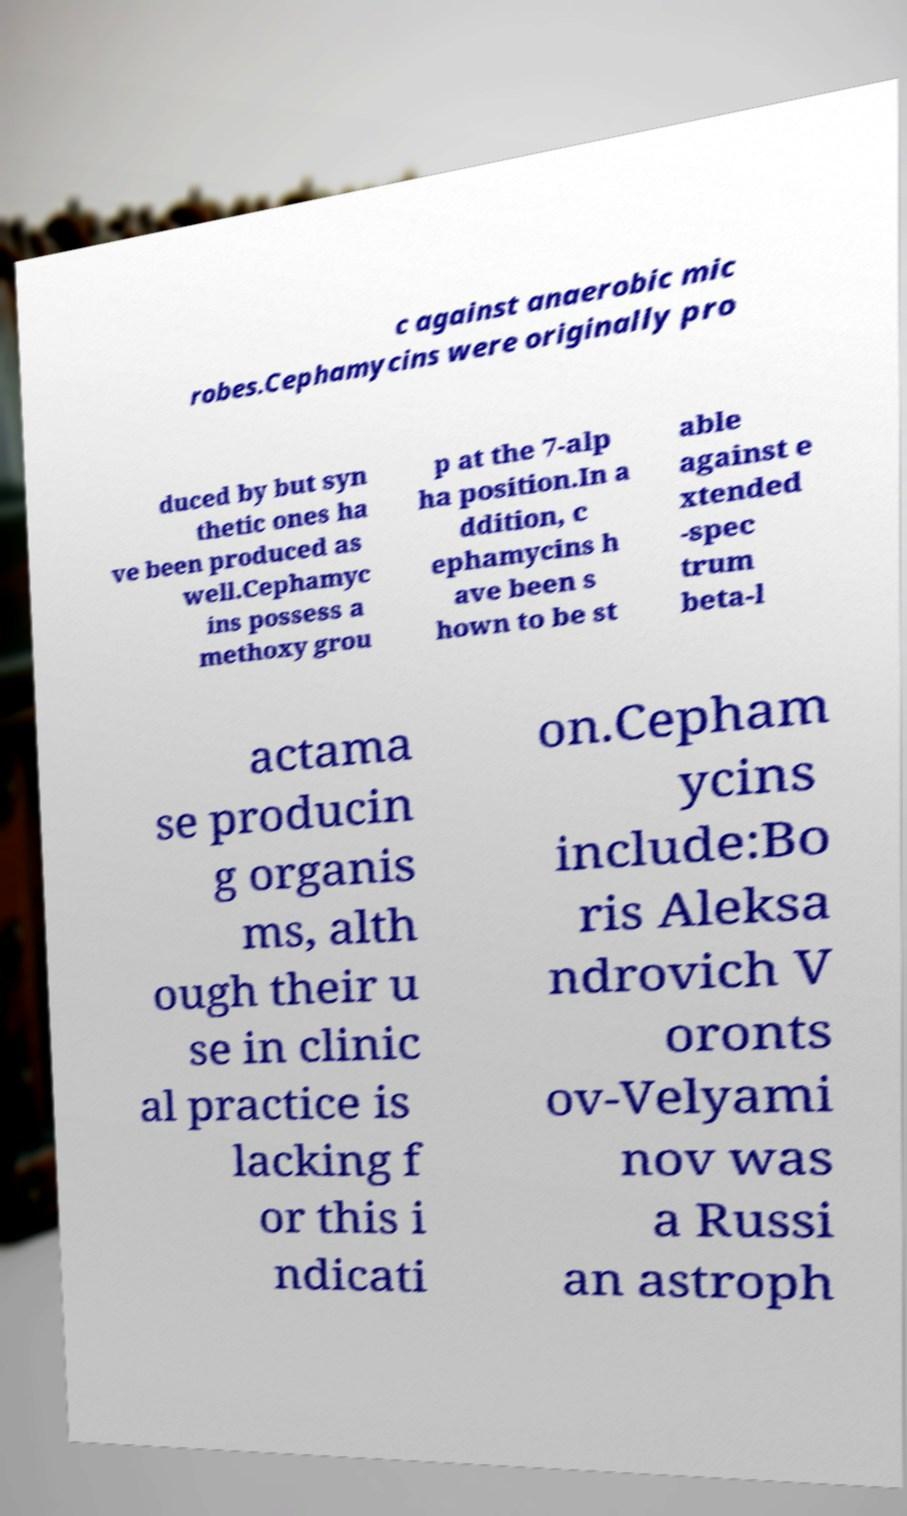Could you extract and type out the text from this image? c against anaerobic mic robes.Cephamycins were originally pro duced by but syn thetic ones ha ve been produced as well.Cephamyc ins possess a methoxy grou p at the 7-alp ha position.In a ddition, c ephamycins h ave been s hown to be st able against e xtended -spec trum beta-l actama se producin g organis ms, alth ough their u se in clinic al practice is lacking f or this i ndicati on.Cepham ycins include:Bo ris Aleksa ndrovich V oronts ov-Velyami nov was a Russi an astroph 